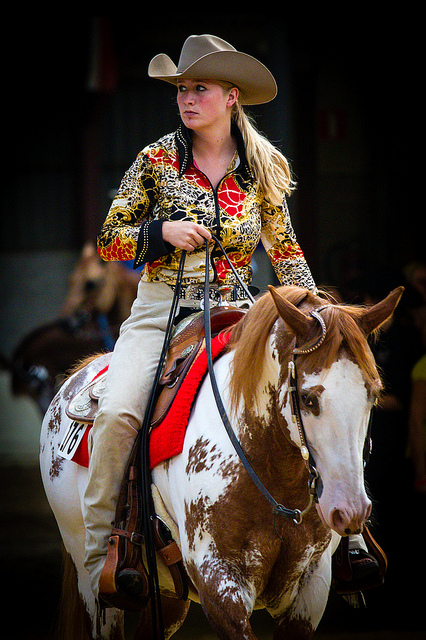How many zebra are here? There are no zebras visible in this image. The photo shows a person riding a horse that has brown and white coloring, which might be confused with a zebra's stripes at a quick glance. But upon closer examination, it's clear that it's a horse, not a zebra. 